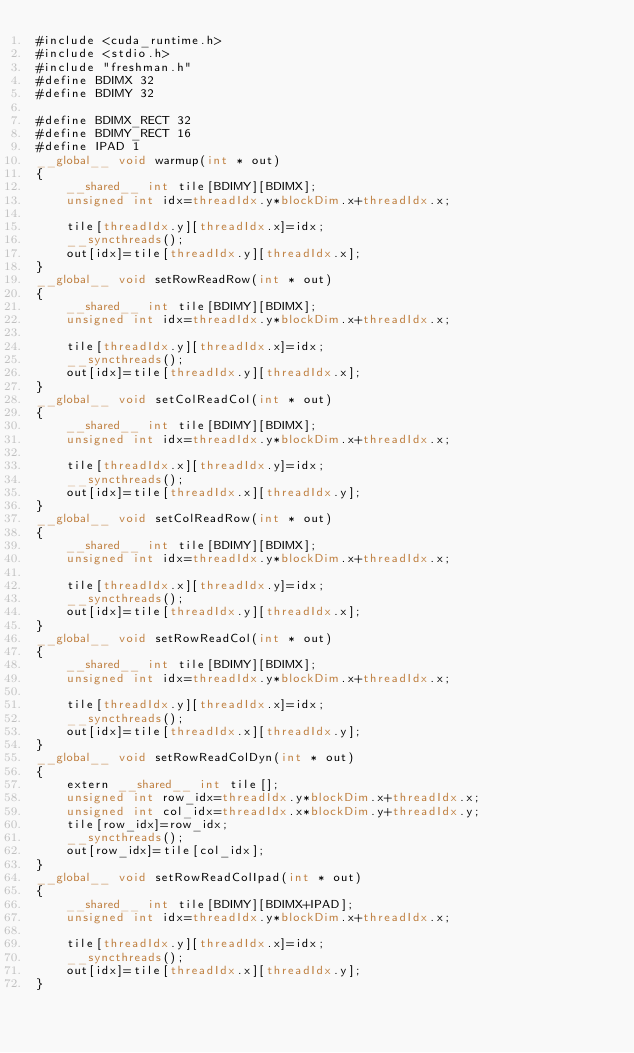<code> <loc_0><loc_0><loc_500><loc_500><_Cuda_>#include <cuda_runtime.h>
#include <stdio.h>
#include "freshman.h"
#define BDIMX 32
#define BDIMY 32

#define BDIMX_RECT 32
#define BDIMY_RECT 16
#define IPAD 1
__global__ void warmup(int * out)
{
    __shared__ int tile[BDIMY][BDIMX];
    unsigned int idx=threadIdx.y*blockDim.x+threadIdx.x;

    tile[threadIdx.y][threadIdx.x]=idx;
    __syncthreads();
    out[idx]=tile[threadIdx.y][threadIdx.x];
}
__global__ void setRowReadRow(int * out)
{
    __shared__ int tile[BDIMY][BDIMX];
    unsigned int idx=threadIdx.y*blockDim.x+threadIdx.x;

    tile[threadIdx.y][threadIdx.x]=idx;
    __syncthreads();
    out[idx]=tile[threadIdx.y][threadIdx.x];
}
__global__ void setColReadCol(int * out)
{
    __shared__ int tile[BDIMY][BDIMX];
    unsigned int idx=threadIdx.y*blockDim.x+threadIdx.x;

    tile[threadIdx.x][threadIdx.y]=idx;
    __syncthreads();
    out[idx]=tile[threadIdx.x][threadIdx.y];
}
__global__ void setColReadRow(int * out)
{
    __shared__ int tile[BDIMY][BDIMX];
    unsigned int idx=threadIdx.y*blockDim.x+threadIdx.x;

    tile[threadIdx.x][threadIdx.y]=idx;
    __syncthreads();
    out[idx]=tile[threadIdx.y][threadIdx.x];
}
__global__ void setRowReadCol(int * out)
{
    __shared__ int tile[BDIMY][BDIMX];
    unsigned int idx=threadIdx.y*blockDim.x+threadIdx.x;

    tile[threadIdx.y][threadIdx.x]=idx;
    __syncthreads();
    out[idx]=tile[threadIdx.x][threadIdx.y];
}
__global__ void setRowReadColDyn(int * out)
{
    extern __shared__ int tile[];
    unsigned int row_idx=threadIdx.y*blockDim.x+threadIdx.x;
    unsigned int col_idx=threadIdx.x*blockDim.y+threadIdx.y;
    tile[row_idx]=row_idx;
    __syncthreads();
    out[row_idx]=tile[col_idx];
}
__global__ void setRowReadColIpad(int * out)
{
    __shared__ int tile[BDIMY][BDIMX+IPAD];
    unsigned int idx=threadIdx.y*blockDim.x+threadIdx.x;

    tile[threadIdx.y][threadIdx.x]=idx;
    __syncthreads();
    out[idx]=tile[threadIdx.x][threadIdx.y];
}</code> 